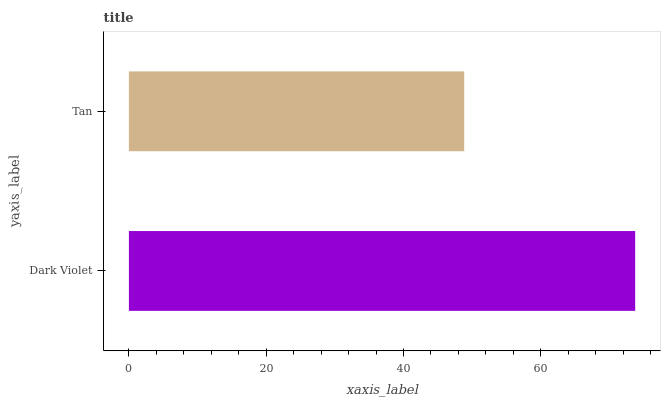Is Tan the minimum?
Answer yes or no. Yes. Is Dark Violet the maximum?
Answer yes or no. Yes. Is Tan the maximum?
Answer yes or no. No. Is Dark Violet greater than Tan?
Answer yes or no. Yes. Is Tan less than Dark Violet?
Answer yes or no. Yes. Is Tan greater than Dark Violet?
Answer yes or no. No. Is Dark Violet less than Tan?
Answer yes or no. No. Is Dark Violet the high median?
Answer yes or no. Yes. Is Tan the low median?
Answer yes or no. Yes. Is Tan the high median?
Answer yes or no. No. Is Dark Violet the low median?
Answer yes or no. No. 